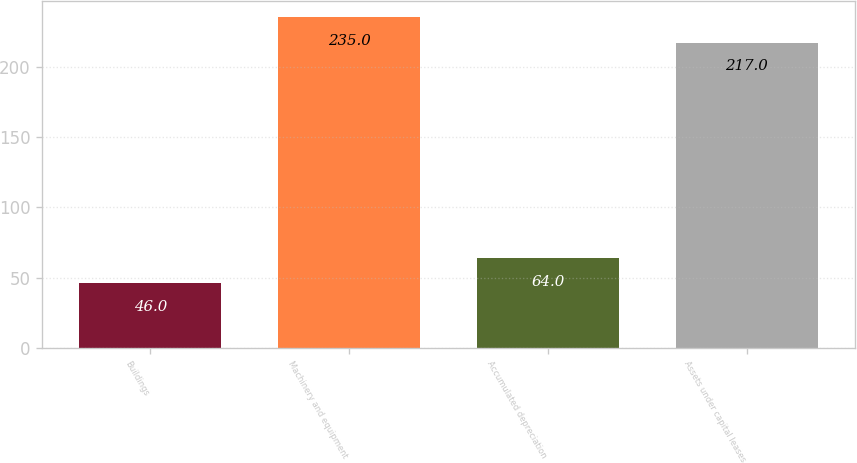Convert chart. <chart><loc_0><loc_0><loc_500><loc_500><bar_chart><fcel>Buildings<fcel>Machinery and equipment<fcel>Accumulated depreciation<fcel>Assets under capital leases<nl><fcel>46<fcel>235<fcel>64<fcel>217<nl></chart> 